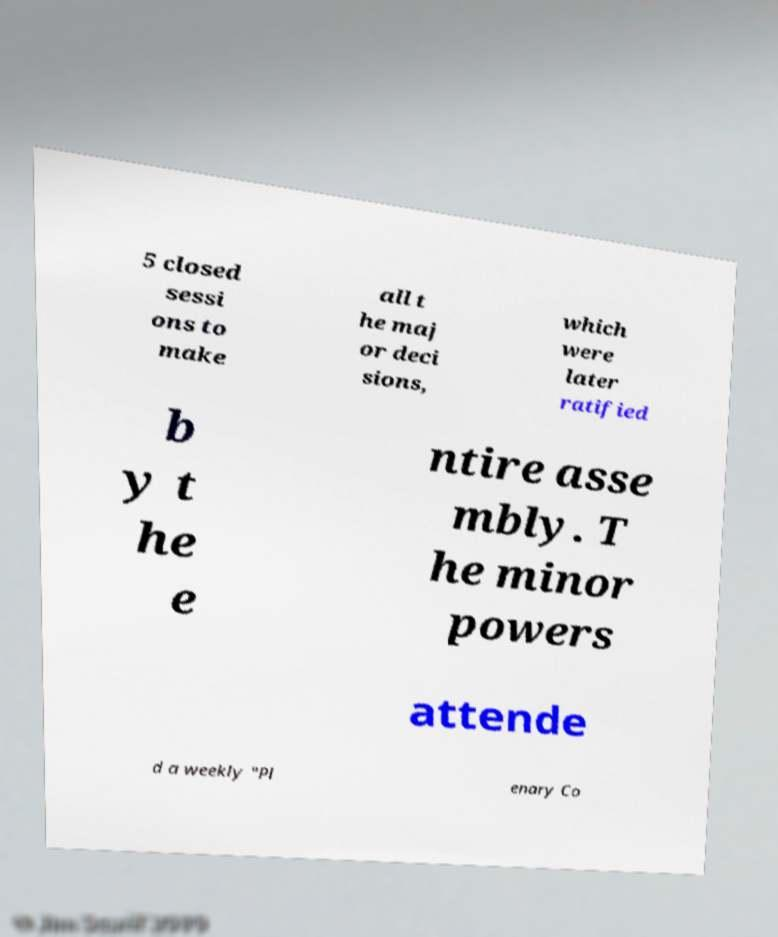Could you extract and type out the text from this image? 5 closed sessi ons to make all t he maj or deci sions, which were later ratified b y t he e ntire asse mbly. T he minor powers attende d a weekly "Pl enary Co 